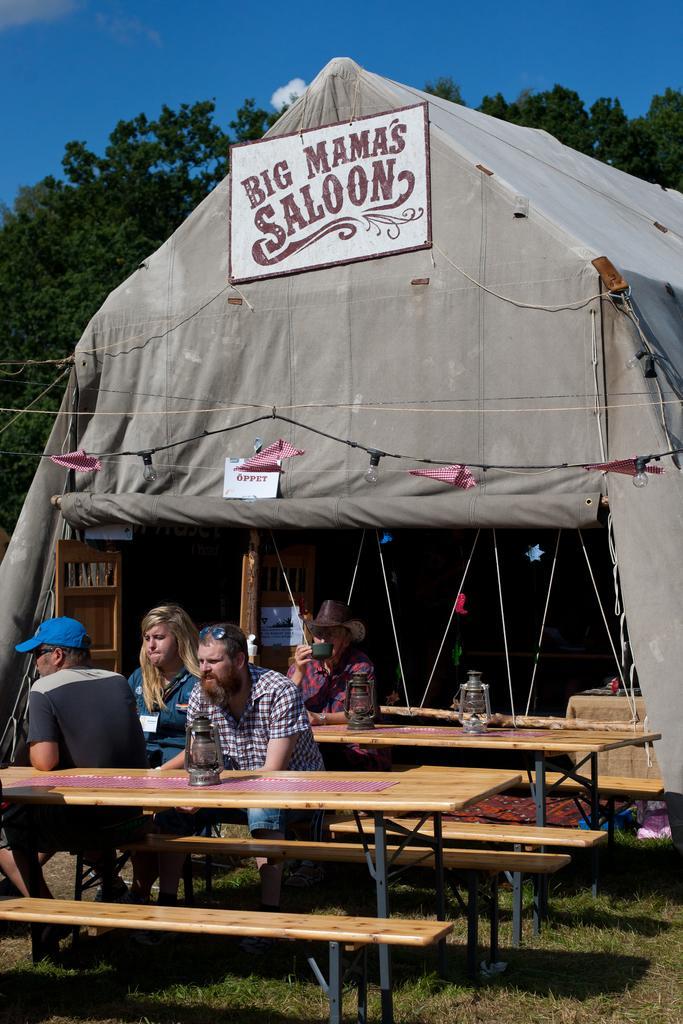How would you summarize this image in a sentence or two? In this image four people sitting on wooden benches with some lanthers and I can see a tent with boards and some text on boards and I can see trees behind the tent and at the top of the image I can see the sky.  